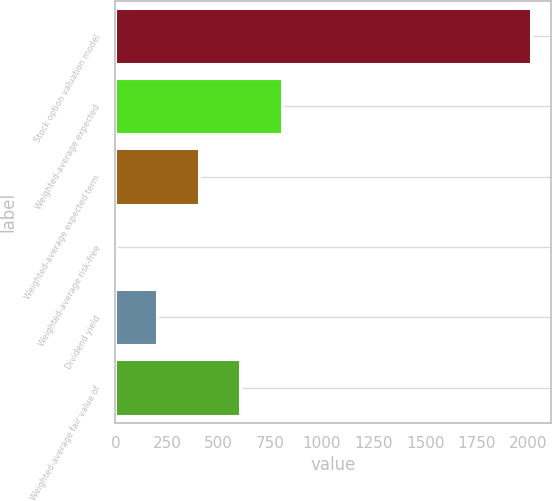Convert chart to OTSL. <chart><loc_0><loc_0><loc_500><loc_500><bar_chart><fcel>Stock option valuation model<fcel>Weighted-average expected<fcel>Weighted-average expected term<fcel>Weighted-average risk-free<fcel>Dividend yield<fcel>Weighted-average fair value of<nl><fcel>2011<fcel>806.22<fcel>404.64<fcel>3.06<fcel>203.85<fcel>605.43<nl></chart> 